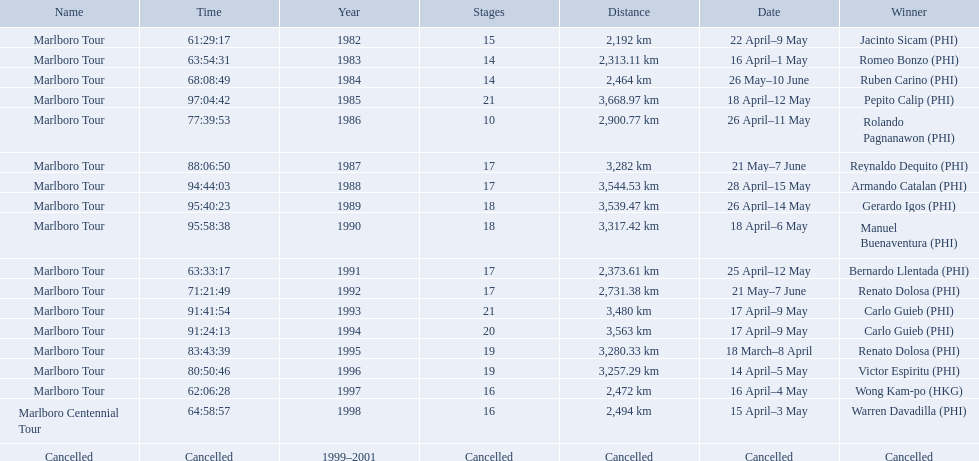What are the distances travelled on the tour? 2,192 km, 2,313.11 km, 2,464 km, 3,668.97 km, 2,900.77 km, 3,282 km, 3,544.53 km, 3,539.47 km, 3,317.42 km, 2,373.61 km, 2,731.38 km, 3,480 km, 3,563 km, 3,280.33 km, 3,257.29 km, 2,472 km, 2,494 km. Which of these are the largest? 3,668.97 km. 